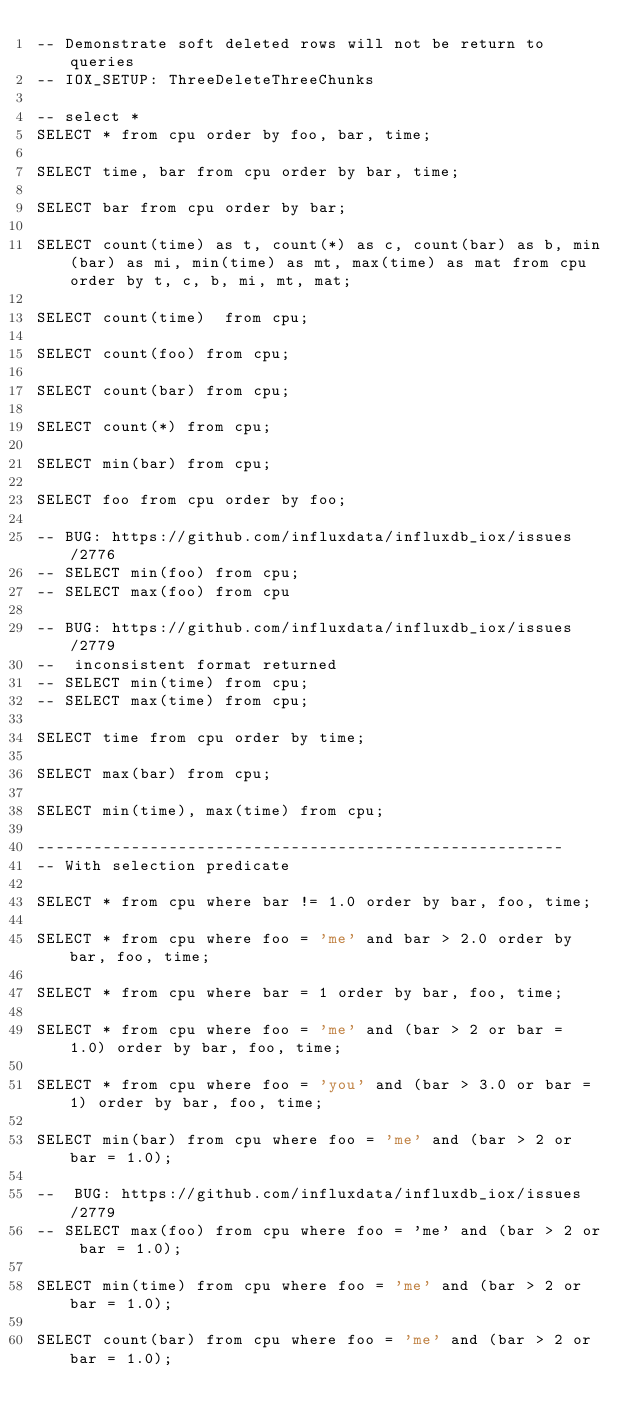Convert code to text. <code><loc_0><loc_0><loc_500><loc_500><_SQL_>-- Demonstrate soft deleted rows will not be return to queries
-- IOX_SETUP: ThreeDeleteThreeChunks

-- select *
SELECT * from cpu order by foo, bar, time;

SELECT time, bar from cpu order by bar, time;

SELECT bar from cpu order by bar;

SELECT count(time) as t, count(*) as c, count(bar) as b, min(bar) as mi, min(time) as mt, max(time) as mat from cpu order by t, c, b, mi, mt, mat;

SELECT count(time)  from cpu;

SELECT count(foo) from cpu;

SELECT count(bar) from cpu;

SELECT count(*) from cpu;

SELECT min(bar) from cpu;

SELECT foo from cpu order by foo;

-- BUG: https://github.com/influxdata/influxdb_iox/issues/2776
-- SELECT min(foo) from cpu;
-- SELECT max(foo) from cpu

-- BUG: https://github.com/influxdata/influxdb_iox/issues/2779
--  inconsistent format returned
-- SELECT min(time) from cpu;
-- SELECT max(time) from cpu;

SELECT time from cpu order by time;

SELECT max(bar) from cpu;

SELECT min(time), max(time) from cpu;

--------------------------------------------------------
-- With selection predicate

SELECT * from cpu where bar != 1.0 order by bar, foo, time;

SELECT * from cpu where foo = 'me' and bar > 2.0 order by bar, foo, time;

SELECT * from cpu where bar = 1 order by bar, foo, time;

SELECT * from cpu where foo = 'me' and (bar > 2 or bar = 1.0) order by bar, foo, time;

SELECT * from cpu where foo = 'you' and (bar > 3.0 or bar = 1) order by bar, foo, time;

SELECT min(bar) from cpu where foo = 'me' and (bar > 2 or bar = 1.0);

--  BUG: https://github.com/influxdata/influxdb_iox/issues/2779
-- SELECT max(foo) from cpu where foo = 'me' and (bar > 2 or bar = 1.0);

SELECT min(time) from cpu where foo = 'me' and (bar > 2 or bar = 1.0);

SELECT count(bar) from cpu where foo = 'me' and (bar > 2 or bar = 1.0);
</code> 